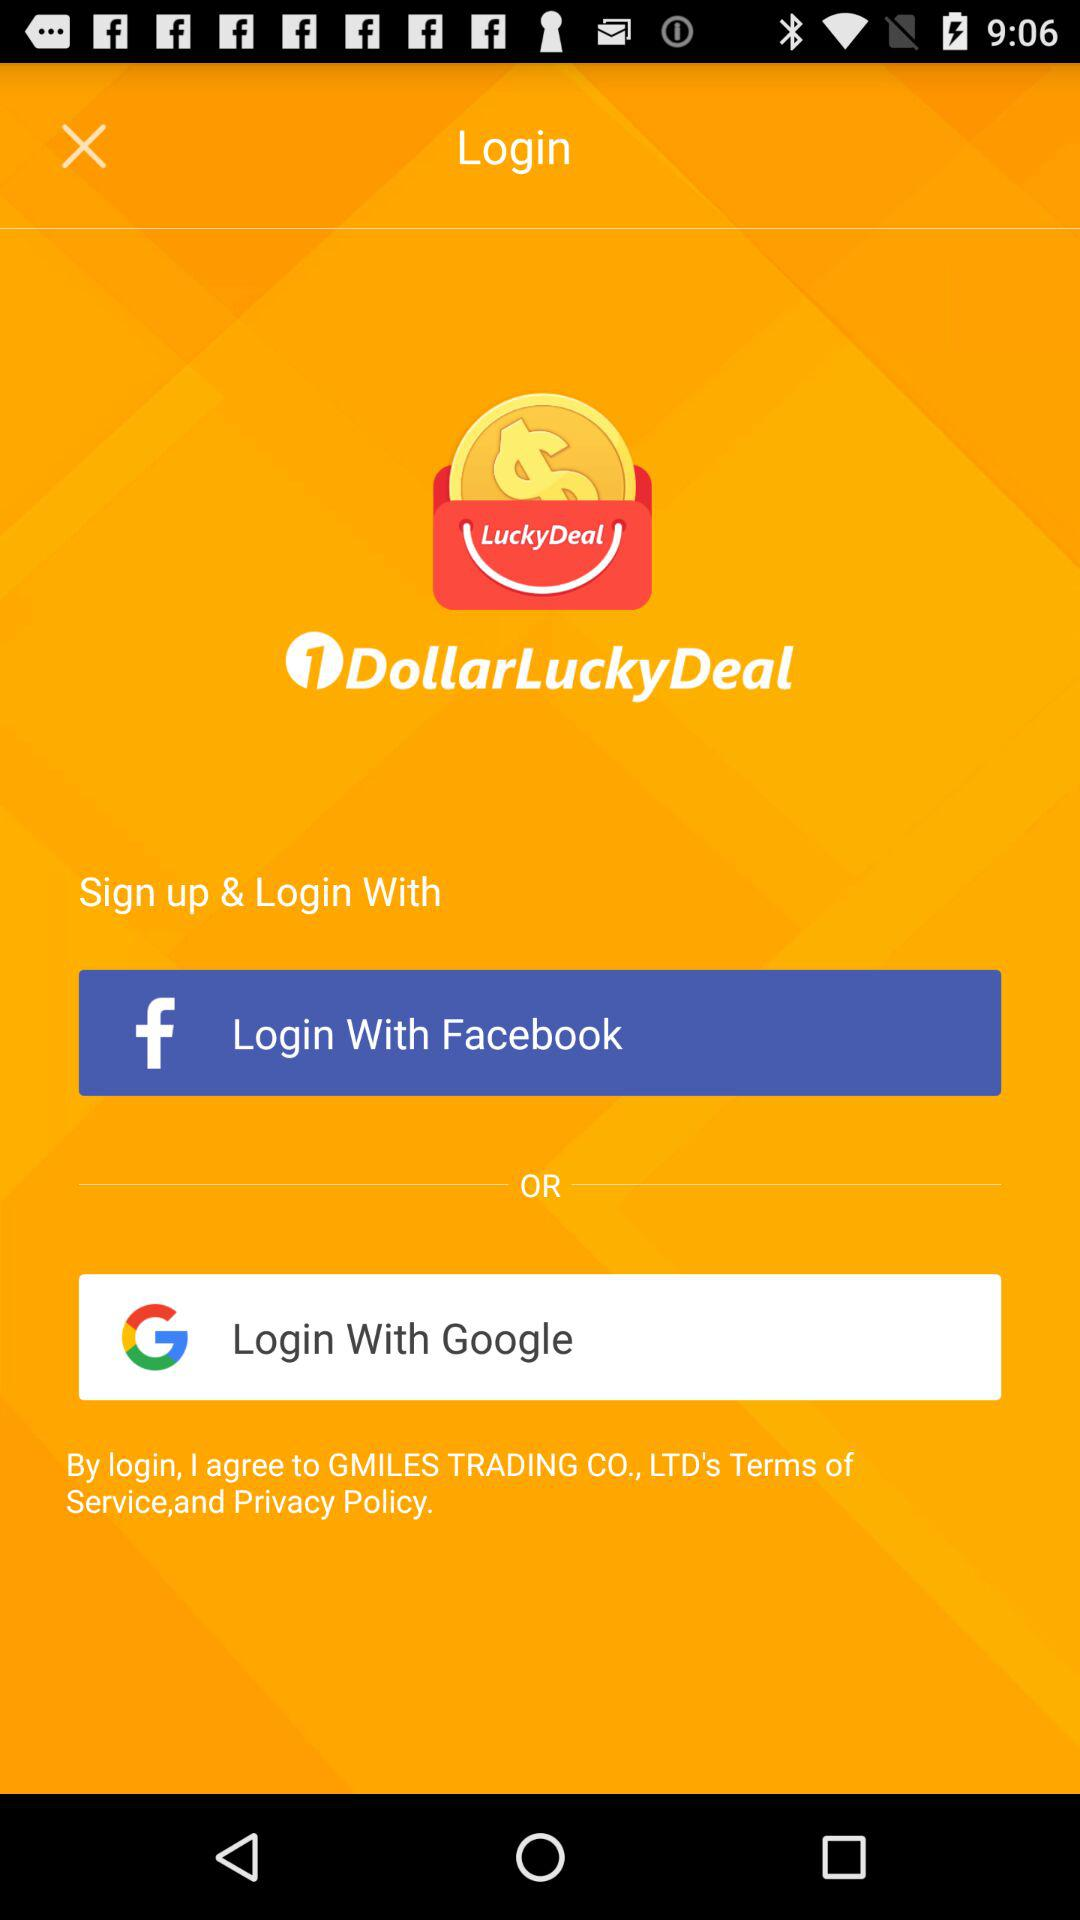How many social media login options are there?
Answer the question using a single word or phrase. 2 